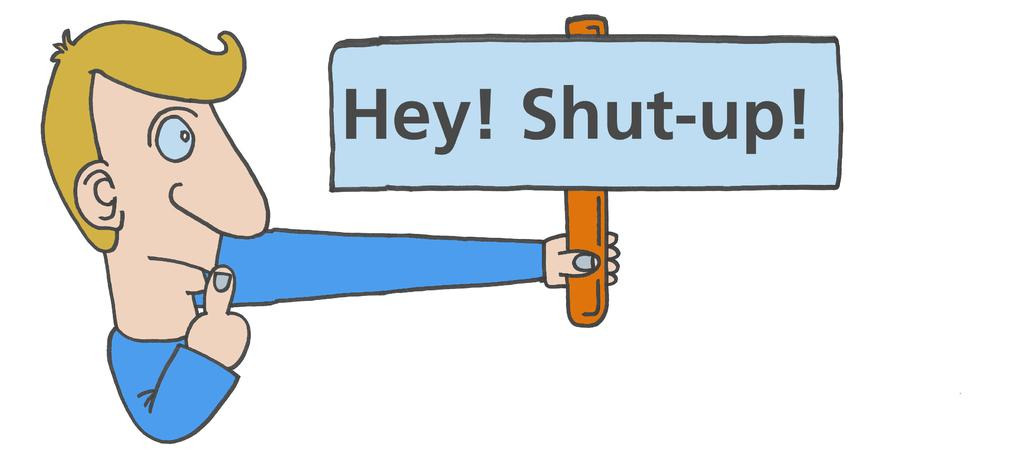What type of image is being described? The image is animated. Who is present in the image? There is a man in the image. What is the man holding in the image? The man is holding a board. What is written on the board? The board has the text "Hey shut up!" on it. What color is the tent in the image? There is no tent present in the image. How does the man wash his ear in the image? There is no mention of the man washing his ear or any ear-related activity in the image. 